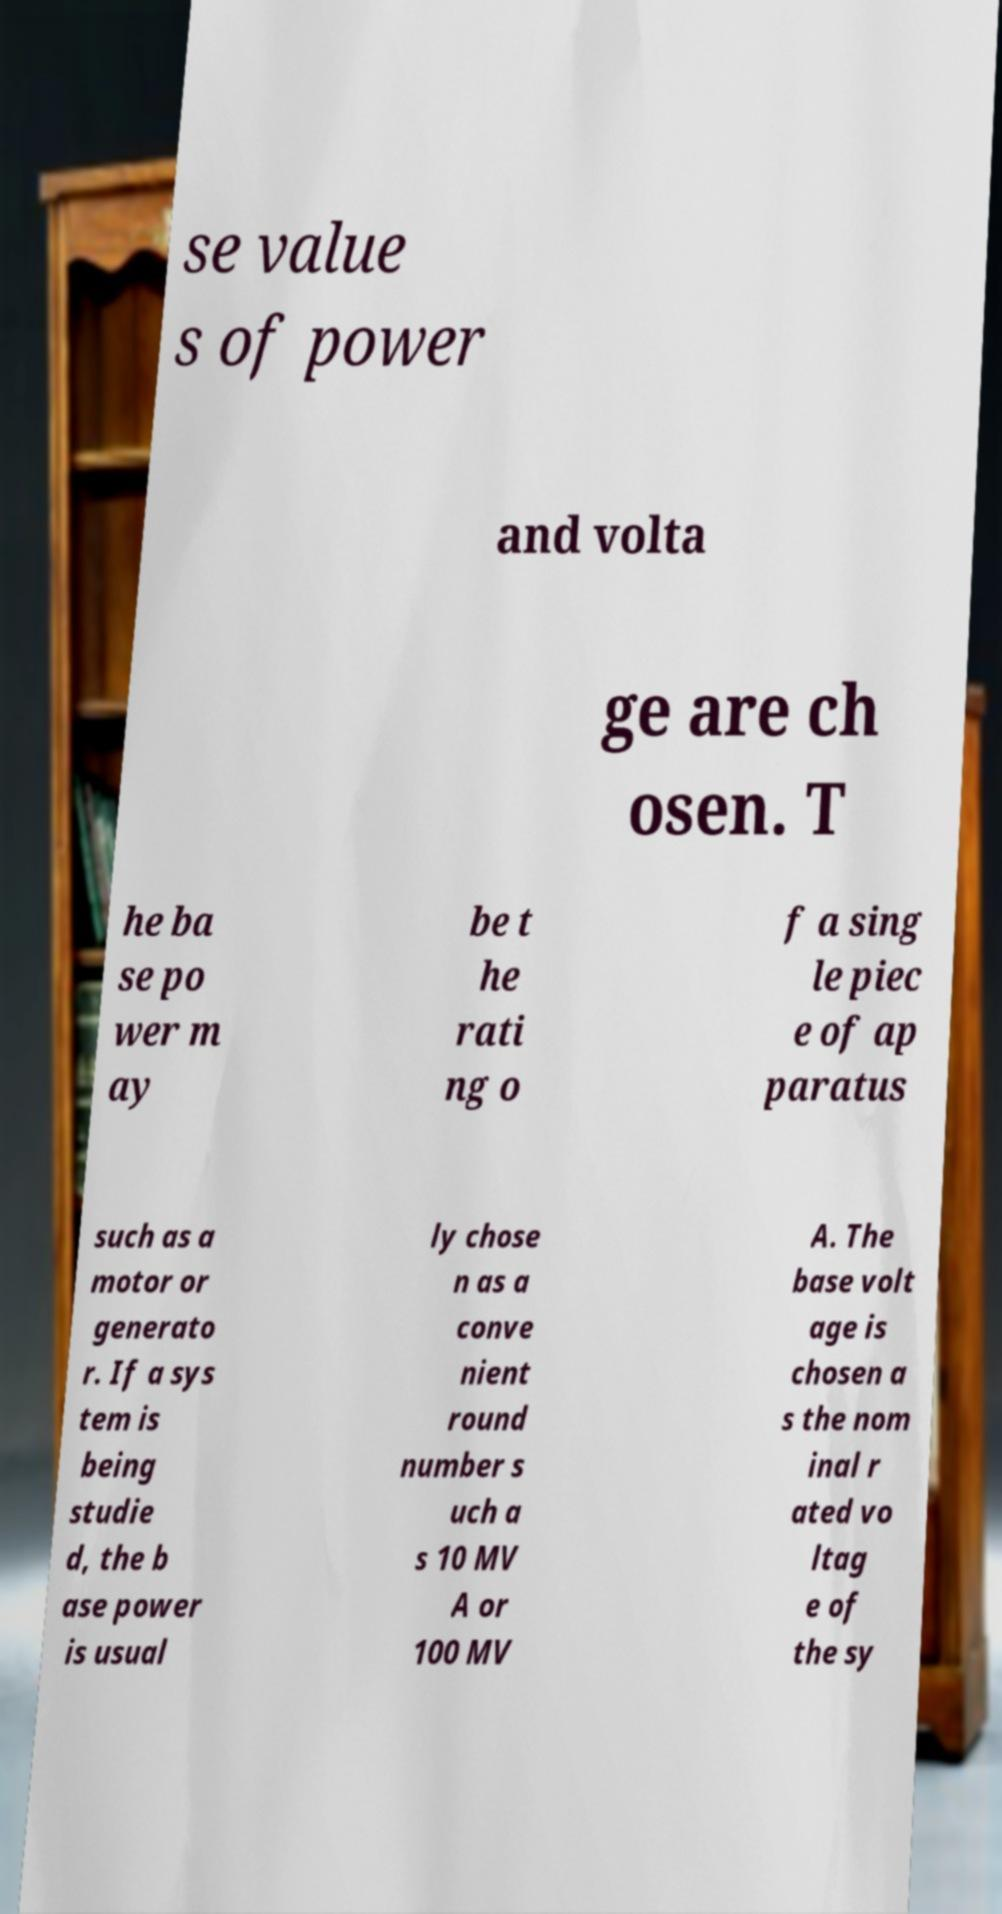Could you extract and type out the text from this image? se value s of power and volta ge are ch osen. T he ba se po wer m ay be t he rati ng o f a sing le piec e of ap paratus such as a motor or generato r. If a sys tem is being studie d, the b ase power is usual ly chose n as a conve nient round number s uch a s 10 MV A or 100 MV A. The base volt age is chosen a s the nom inal r ated vo ltag e of the sy 